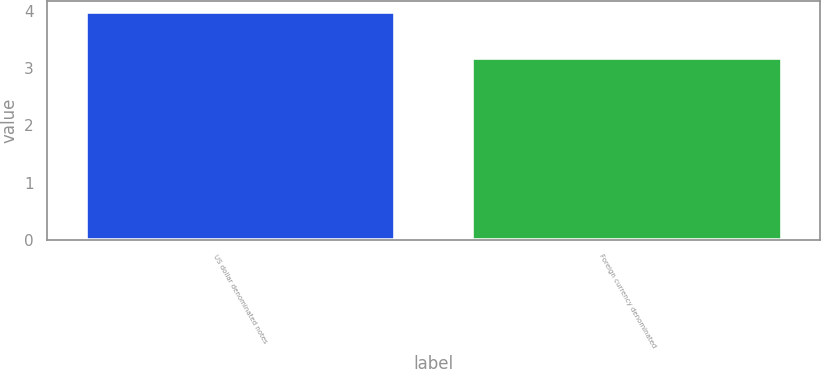Convert chart to OTSL. <chart><loc_0><loc_0><loc_500><loc_500><bar_chart><fcel>US dollar denominated notes<fcel>Foreign currency denominated<nl><fcel>3.97<fcel>3.18<nl></chart> 